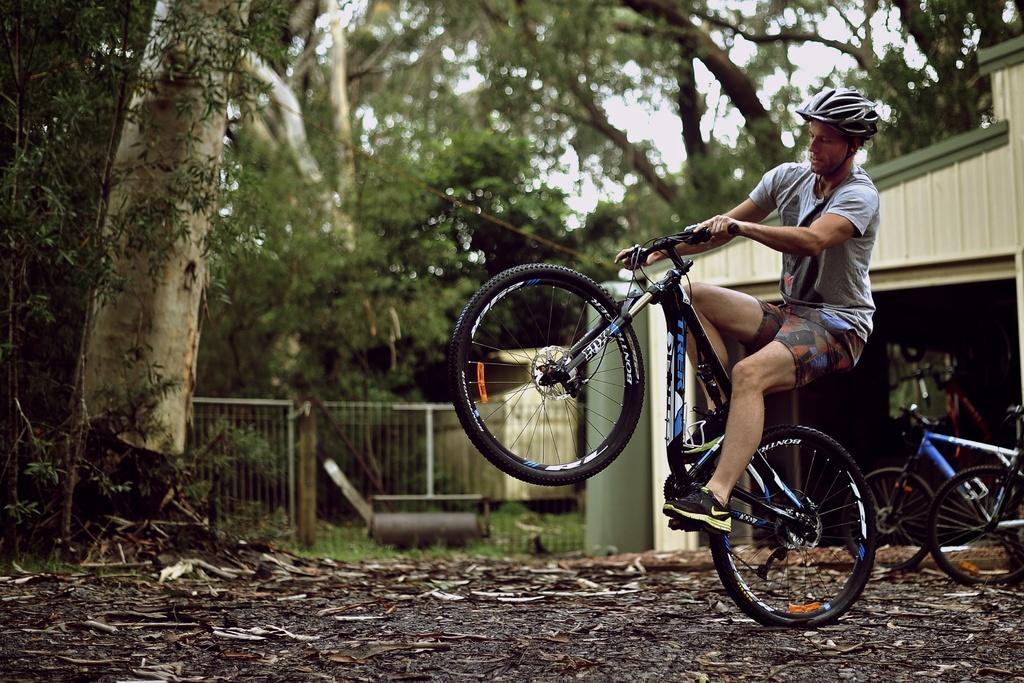Describe this image in one or two sentences. In this picture we can see a man on the bicycle. He wear a helmet. On the background there are trees. And this is sky. 